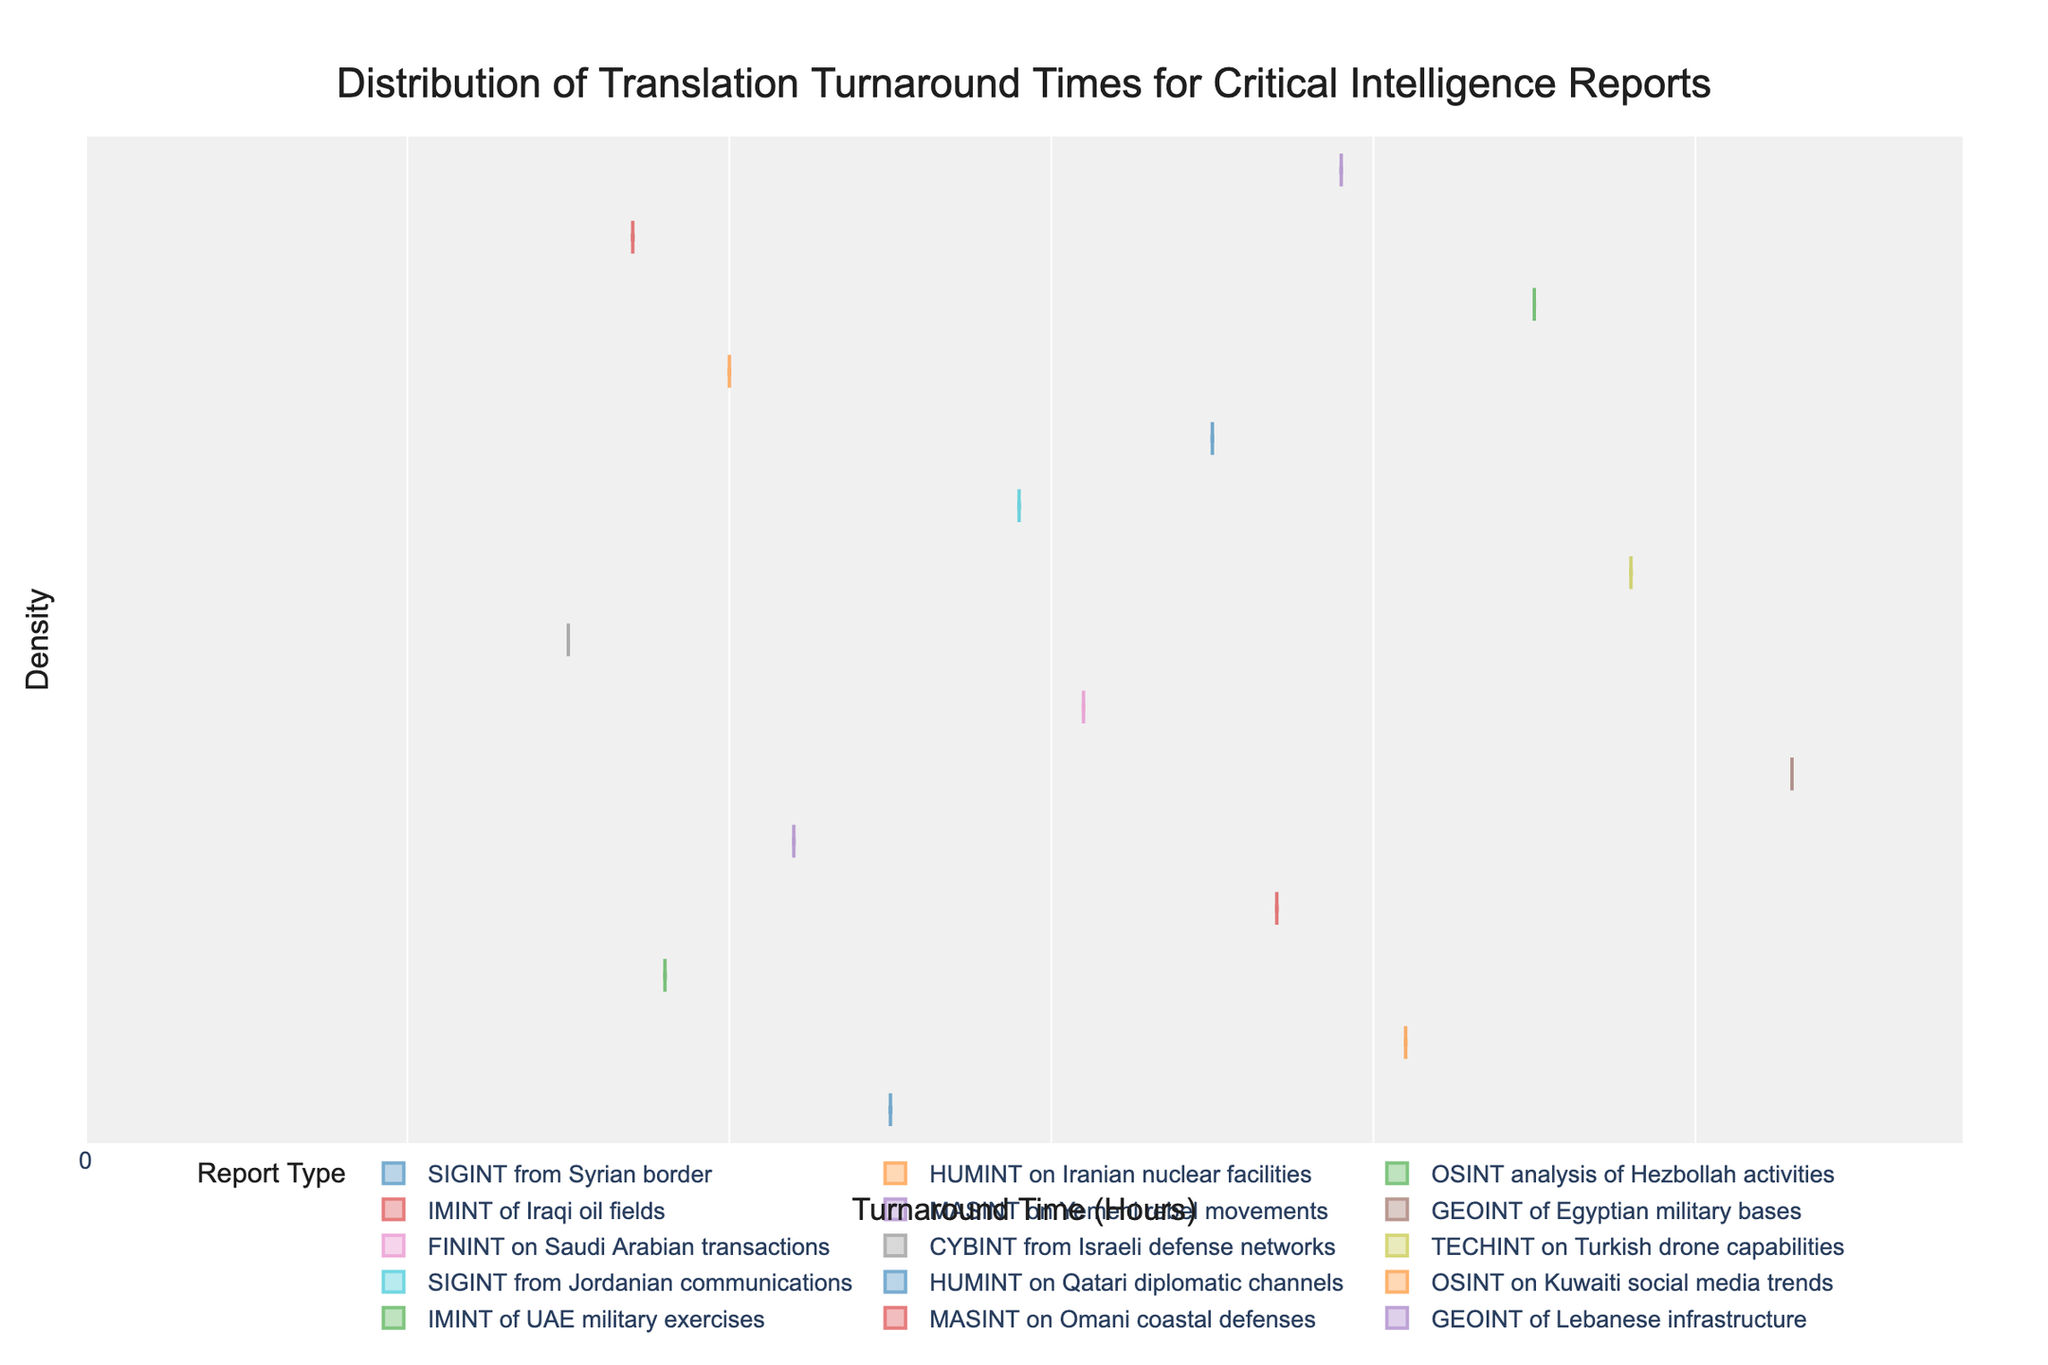What is the title of the plot? The title is usually prominently displayed, so looking at the top center of the plot will reveal it: "Distribution of Translation Turnaround Times for Critical Intelligence Reports".
Answer: Distribution of Translation Turnaround Times for Critical Intelligence Reports What do the x-axis labels represent? The label on the x-axis shows that it represents the turnaround time in hours. This information is crucial as it lets us know what the data points are measuring.
Answer: Turnaround Time (Hours) How many types of reports are displayed in the legend? Each unique colored legend entry denotes a different type of report. By counting them, we see there are multiple types but we must check the legend to identify the exact number.
Answer: 15 Which report type has the longest turnaround time? By examining the spread and length of the density plots along the x-axis, the longest length corresponds to one specific report type. In this case, it is the GEOINT of Egyptian military bases with the highest endpoint around 5.3 hours.
Answer: GEOINT of Egyptian military bases What is the shortest turnaround time observed and for which report type? To determine the shortest time, look at the minimum values in all the density distributions. Here, the shortest is around 1.5 hours for CYBINT from Israeli defense networks.
Answer: 1.5 hours for CYBINT from Israeli defense networks How does the median turnaround time for HUMINT on Iranian nuclear facilities compare to that of TECHINT on Turkish drone capabilities? By looking at the middle line (median) in the density plot of each report type, we can compare their positions on the x-axis. Notice the median line for HUMINT on Iranian nuclear facilities is at 4.1 hours, while the median for TECHINT on Turkish drone capabilities is at 4.8 hours.
Answer: 4.1 hours vs 4.8 hours Which report has the smallest interquartile range (box size within the violin plot)? The interquartile range can be observed as the width of the box within each violin plot. The smaller this box, the smaller the interquartile range. Observing all plots, the CYBINT from Israeli defense networks has the smallest box.
Answer: CYBINT from Israeli defense networks What is the mean turnaround time for FININT on Saudi Arabian transactions? The mean is shown by a line (usually a line in a different style) within the violin plot. For FININT on Saudi Arabian transactions, this is around 3.1 hours visible in the plot.
Answer: 3.1 hours Are the turnaround times for IMINT of Iraqi oil fields typically greater or less than the median turnaround time for MASINT on Omani coastal defenses? By comparing the density plots: the turnaround times for IMINT of Iraqi oil fields center around 3.7 hours while the median for MASINT on Omani coastal defenses is 1.7 hours. Typically, the turnaround for IMINT of Iraqi oil fields is greater.
Answer: Greater What is the range of turnaround times for SIGINT from Jordanian communications? The range is determined by looking at the spread of the violin plot for SIGINT from Jordanian communications, which ranges from about 2.9 to below 3.0 hours.
Answer: 2.9 to 3.0 hours 